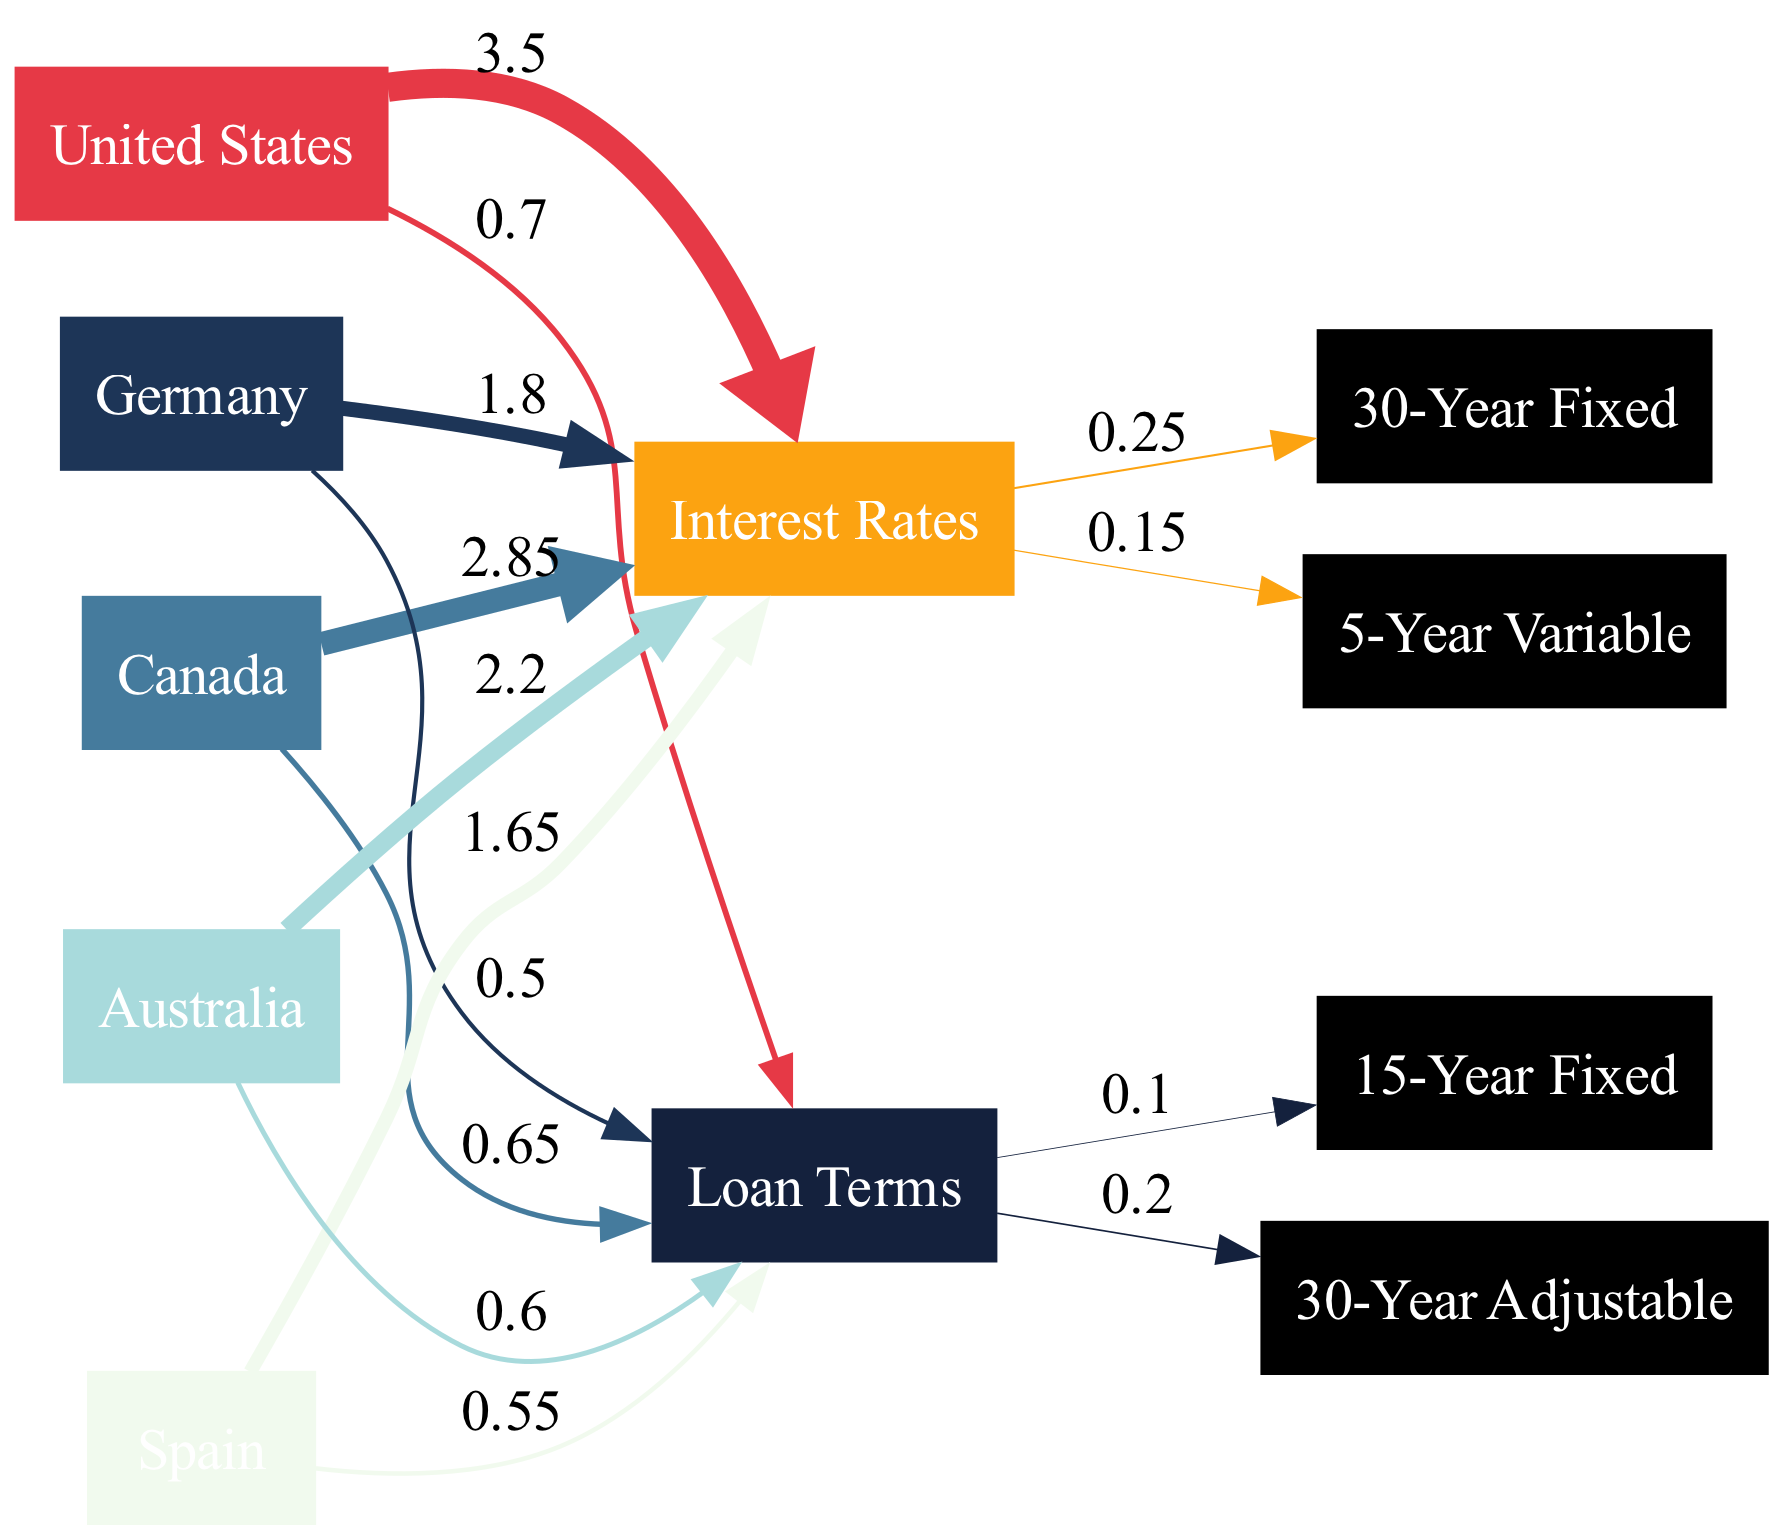What is the interest rate for Germany? The link from Germany to Interest Rates shows a value of 1.8, which represents the interest rate for Germany.
Answer: 1.8 Which country has the highest interest rate? By comparing the values of the links from the countries to Interest Rates, the United States has the highest value at 3.5.
Answer: United States What is the total number of nodes in the diagram? Counting all unique nodes listed in the data, there are 10 nodes in total.
Answer: 10 Which loan term is associated with the highest value? By examining the links from Loan Terms, 30-Year Adjustable has the highest value of 0.2 among its connections.
Answer: 30-Year Adjustable What is the loan term value for Australia? The link from Australia to Loan Terms shows a value of 0.6, representing the loan term for Australia.
Answer: 0.6 Which country's interest rate is closest to 2.2? The value for Australia is 2.2, making it the only country with that exact interest rate.
Answer: Australia What percentage of the interest rates links does the 30-Year Fixed represent? The value for 30-Year Fixed is 0.25. The total of all interest rates values is 3.5 + 2.85 + 1.8 + 1.65 + 2.2 = 12.0. The percentage is (0.25 / 12.0) * 100 ≈ 2.08%.
Answer: 2.08% Which country has the lowest loan term? The link from Germany to Loan Terms shows the lowest value of 0.5 among the countries.
Answer: Germany How many loan term options are presented in the diagram? There are four unique loan term options detailed in the loan terms node.
Answer: Four 